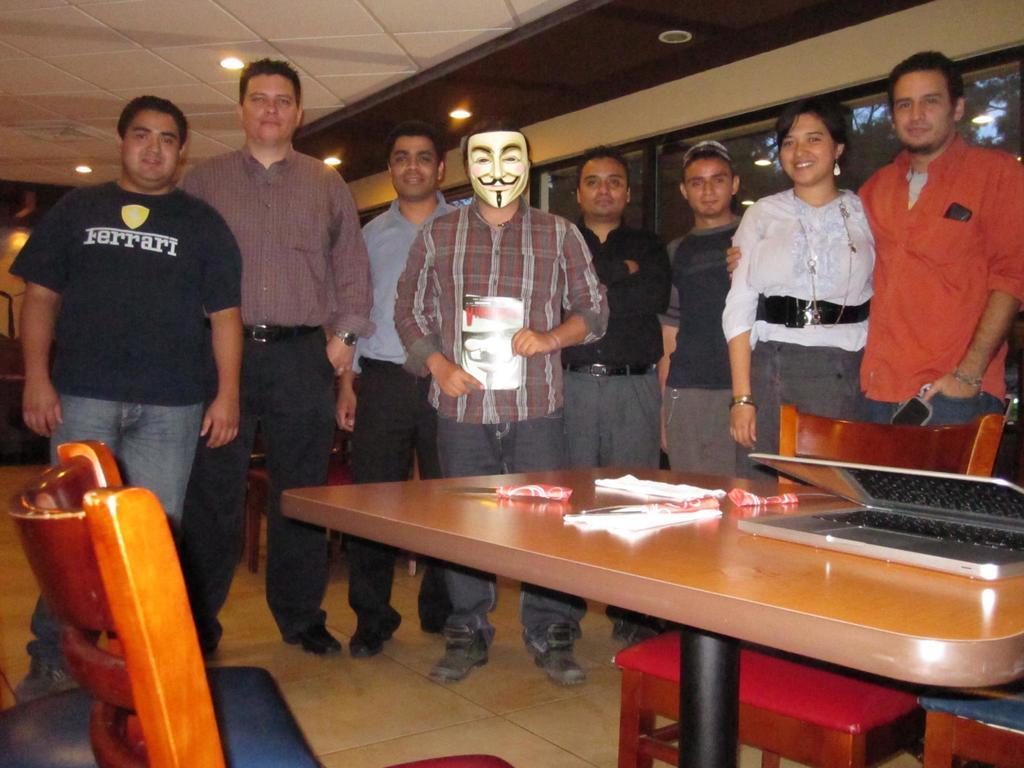Could you give a brief overview of what you see in this image? These group of people are standing. Middle this person wore mask and holding a book. Lights are attached to the ceiling. In-front of this person there is a table, on this table there is a laptop and things. Under the table there is a pole in black color. These are chairs. From this window we can able to see tree. 